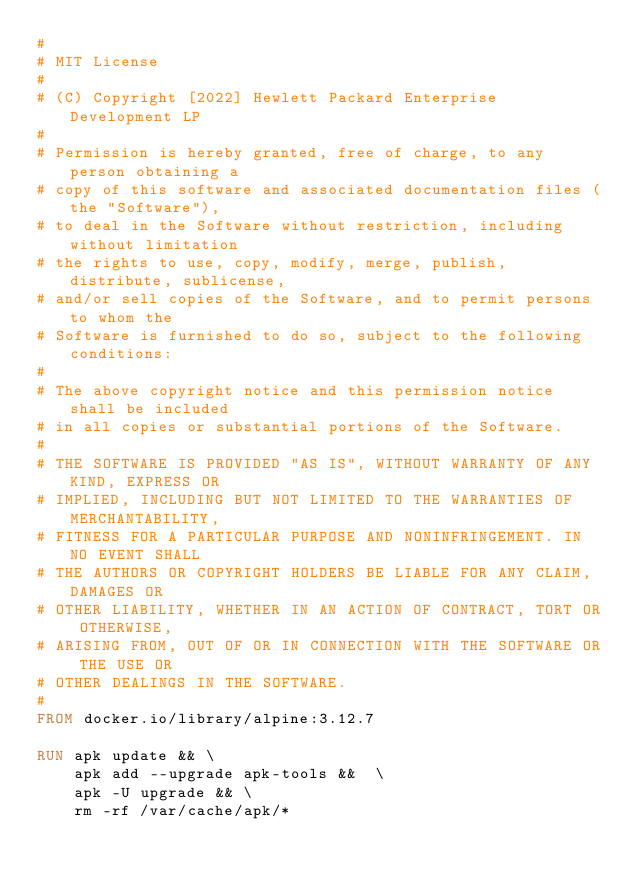<code> <loc_0><loc_0><loc_500><loc_500><_Dockerfile_>#
# MIT License
#
# (C) Copyright [2022] Hewlett Packard Enterprise Development LP
#
# Permission is hereby granted, free of charge, to any person obtaining a
# copy of this software and associated documentation files (the "Software"),
# to deal in the Software without restriction, including without limitation
# the rights to use, copy, modify, merge, publish, distribute, sublicense,
# and/or sell copies of the Software, and to permit persons to whom the
# Software is furnished to do so, subject to the following conditions:
#
# The above copyright notice and this permission notice shall be included
# in all copies or substantial portions of the Software.
#
# THE SOFTWARE IS PROVIDED "AS IS", WITHOUT WARRANTY OF ANY KIND, EXPRESS OR
# IMPLIED, INCLUDING BUT NOT LIMITED TO THE WARRANTIES OF MERCHANTABILITY,
# FITNESS FOR A PARTICULAR PURPOSE AND NONINFRINGEMENT. IN NO EVENT SHALL
# THE AUTHORS OR COPYRIGHT HOLDERS BE LIABLE FOR ANY CLAIM, DAMAGES OR
# OTHER LIABILITY, WHETHER IN AN ACTION OF CONTRACT, TORT OR OTHERWISE,
# ARISING FROM, OUT OF OR IN CONNECTION WITH THE SOFTWARE OR THE USE OR
# OTHER DEALINGS IN THE SOFTWARE.
#
FROM docker.io/library/alpine:3.12.7

RUN apk update && \
    apk add --upgrade apk-tools &&  \
    apk -U upgrade && \
    rm -rf /var/cache/apk/*
</code> 